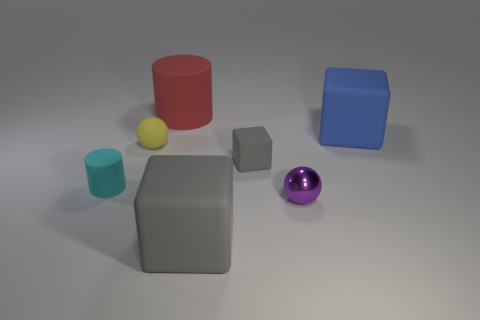Subtract all small blocks. How many blocks are left? 2 Add 3 gray matte objects. How many objects exist? 10 Subtract all cyan balls. How many gray blocks are left? 2 Subtract all blue blocks. How many blocks are left? 2 Subtract all cylinders. How many objects are left? 5 Subtract 1 blocks. How many blocks are left? 2 Subtract all large red things. Subtract all big gray blocks. How many objects are left? 5 Add 7 tiny rubber cubes. How many tiny rubber cubes are left? 8 Add 3 small purple spheres. How many small purple spheres exist? 4 Subtract 0 green cubes. How many objects are left? 7 